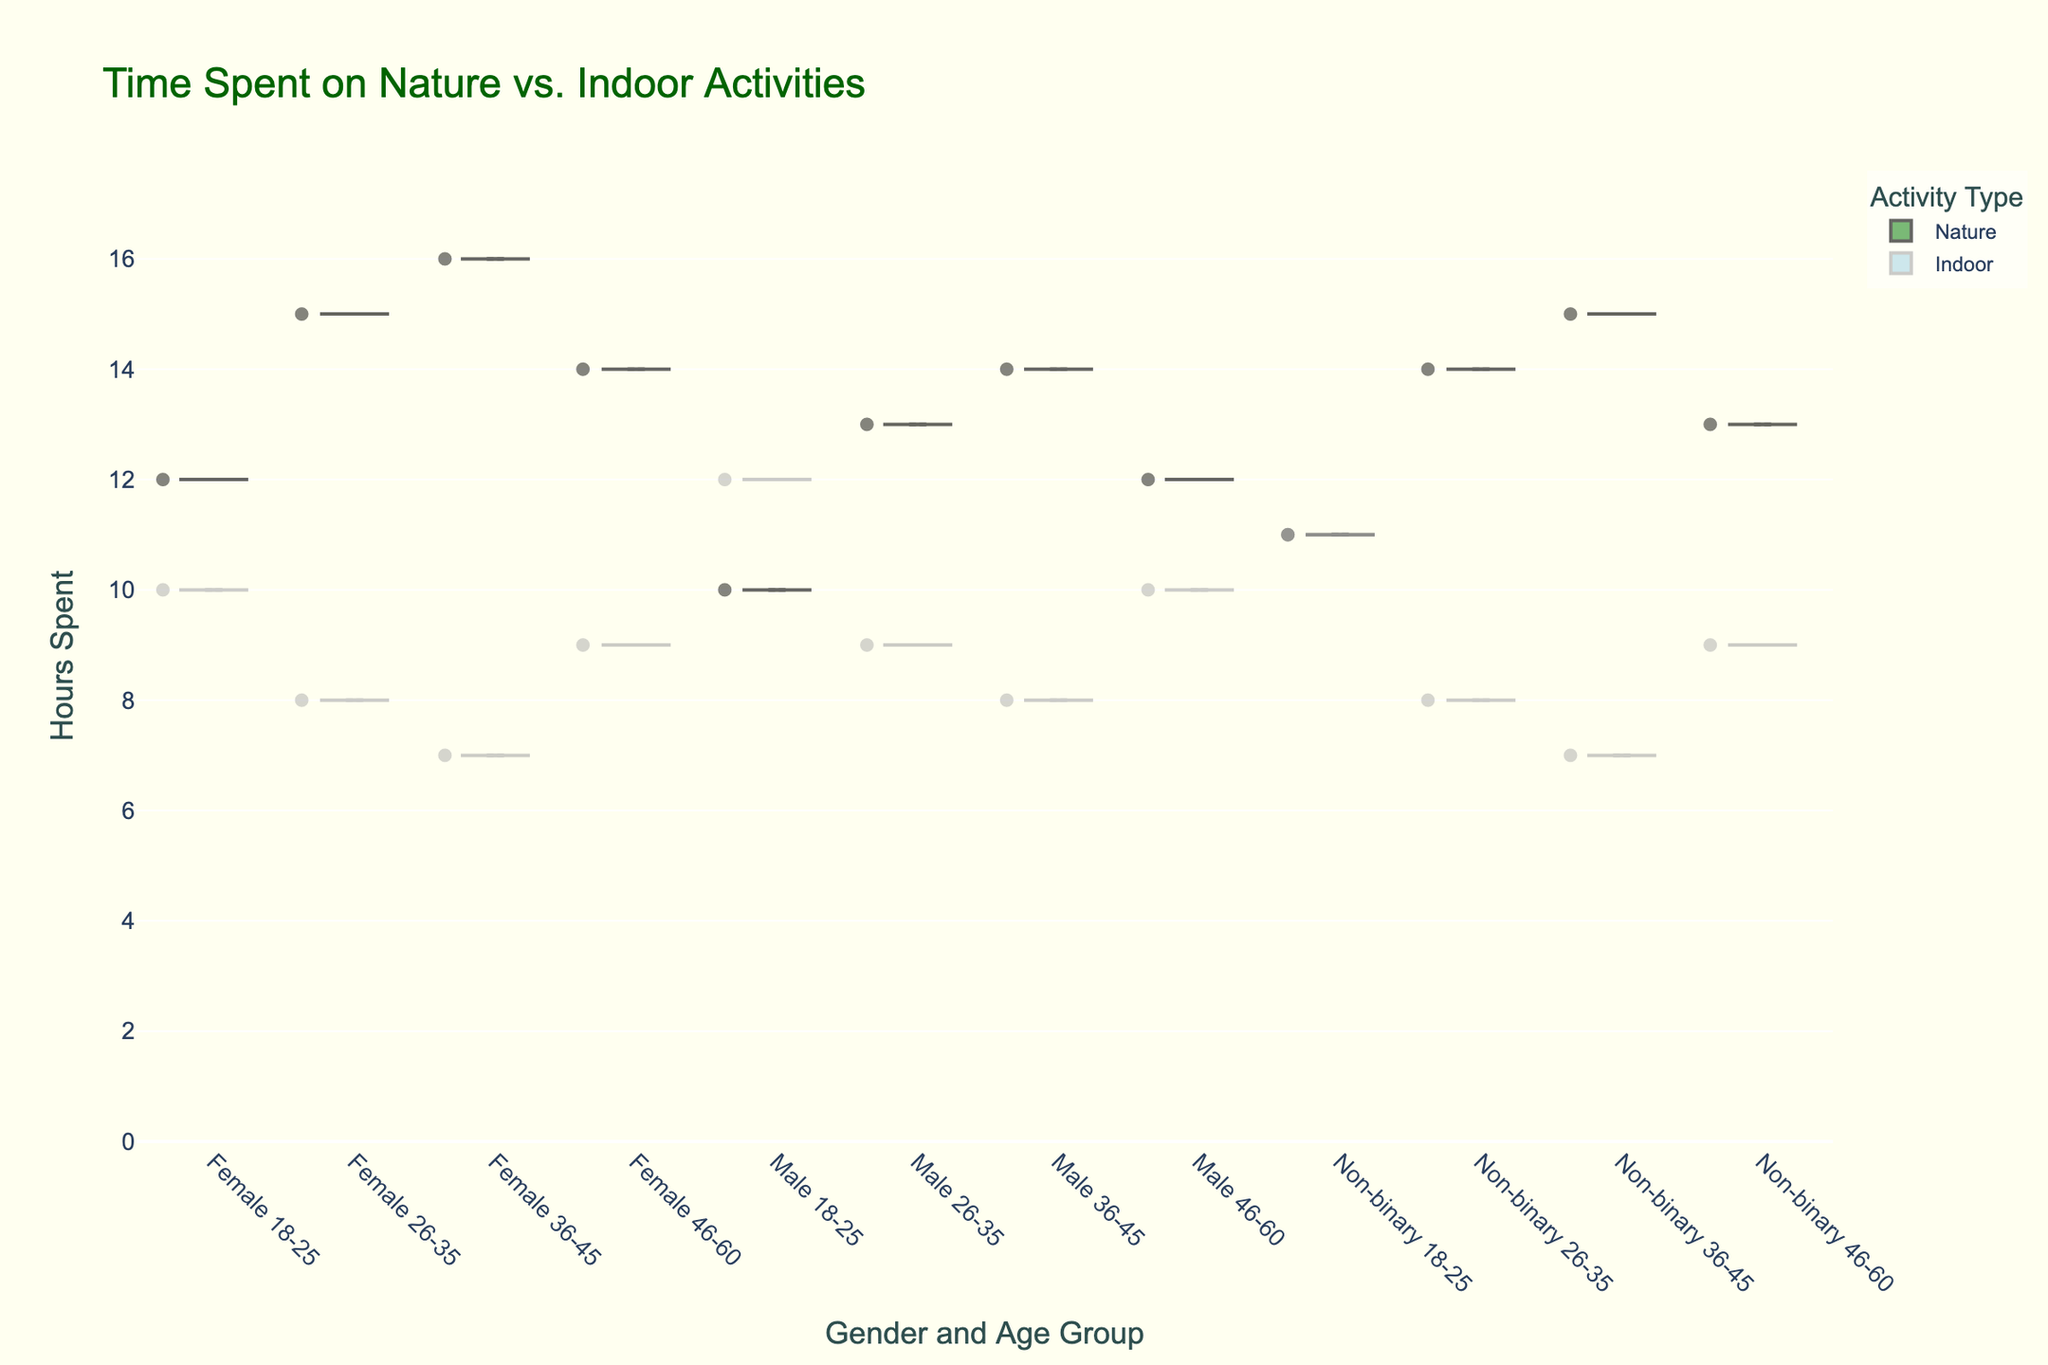What are the two activity types shown in the chart? The chart shows two activity types: "Nature" and "Indoor," which are identified by their distinct colors and labels in the legend.
Answer: Nature, Indoor Which gender and age group combination spends the most time on indoor activities? To find the combination that spends the most time on indoor activities, observe the point that extends the highest within the "Indoor" activity points on the plot. The "Male 18-25" group spends the most time on indoor activities with a maximum of 12 hours.
Answer: Male 18-25 What's the median number of hours spent on nature activities by females aged 36-45? Locate the box plot overlaid on the violin plot for "Female 36-45" under "Nature" activities and check the median line within the box. The median for this group is 16 hours.
Answer: 16 hours Compare the average number of hours spent on indoor activities by males aged 18-25 and those aged 46-60. Which group spends more time? To compare, locate the box plots of "Male 18-25" and "Male 46-60" under "Indoor" activities. For "Male 18-25," the median is 12, and for "Male 46-60," it's 10. Since the median represents the middle value, and both have symmetrical distributions, "Male 18-25" spends more hours on average.
Answer: Male 18-25 How do the distributions of hours spent on nature activities differ between males and non-binary individuals aged 36-45? Observe the shapes of the violin plots for "Male 36-45" and "Non-binary 36-45" under "Nature" activities. Both plots have a median of 14 and 15 hours, respectively, but the distribution for non-binary individuals is a bit wider and centered higher near 15 hours compared to males, whose distribution is more centered around 14 hours.
Answer: Non-binary individuals have a slightly higher distribution What is the maximum number of hours spent on nature activities across all gender and age groups? Check the topmost point in the "Nature" activity section. The highest point for nature activities is 16 hours, observed in the "Female 36-45" group.
Answer: 16 hours Which age group spends more time on indoor activities on average, 18-25 or 36-45? Compare the box plots of the corresponding age groups under "Indoor" activities. The median for "18-25" is higher (11.5) than "36-45" (7.5). Thus, 18-25 age group spends more time on average.
Answer: 18-25 What is the range of hours spent on indoor activities by the non-binary 18-25 group? Look at the "Indoor" violin plot for "Non-binary 18-25" and calculate the range from the minimum to the maximum value. The minimum is around 11 hours and the maximum is also 11 hours, making the range 0.
Answer: 0 hours What can be concluded about the time spent on nature activities by the females aged 26-35 compared to males aged 26-35? By observing the respective violin and box plots under "Nature," both groups show similar median values around 15 hours but the spread for females indicates they might spend slightly more time on nature activities, as the box plot slightly extends above that for males.
Answer: Females spend slightly more time 